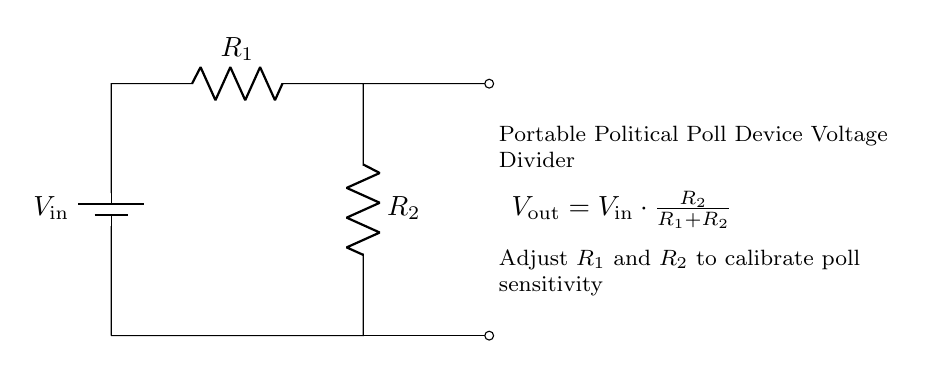What is the function of this circuit? This circuit functions as a voltage divider, allowing the input voltage to be divided into a lower output voltage based on the resistor values.
Answer: Voltage divider What do R1 and R2 represent? R1 and R2 represent resistors in the circuit that determine the division of the input voltage. Their values can be adjusted to change the output voltage.
Answer: Resistors What is the formula for the output voltage? The formula for the output voltage is given in the diagram as Vout equals Vin times the fraction of R2 over the sum of R1 and R2.
Answer: Out = In * (R2 / (R1 + R2)) How can the sensitivity of the poll device be adjusted? The sensitivity of the poll device can be adjusted by changing the values of resistors R1 and R2. This will affect the output voltage for a given input voltage.
Answer: By adjusting R1 and R2 What is the role of Vout in this circuit? Vout represents the output voltage that results from the division of the input voltage across the resistors R1 and R2 according to the voltage divider principle.
Answer: Output voltage after division What happens if R1 is much larger than R2? If R1 is much larger than R2, the output voltage Vout will be significantly lower than the input voltage Vin, nearing zero, as R2 has a smaller effect on the total resistance.
Answer: Vout approaches zero What would be the output voltage if R2 is zero? If R2 is zero, the output voltage Vout would also be zero because there would be no voltage drop across R2, leading to no output voltage in the divider.
Answer: Zero volts 